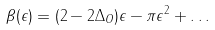Convert formula to latex. <formula><loc_0><loc_0><loc_500><loc_500>\beta ( \epsilon ) = ( 2 - 2 \Delta _ { O } ) \epsilon - \pi \epsilon ^ { 2 } + \dots</formula> 